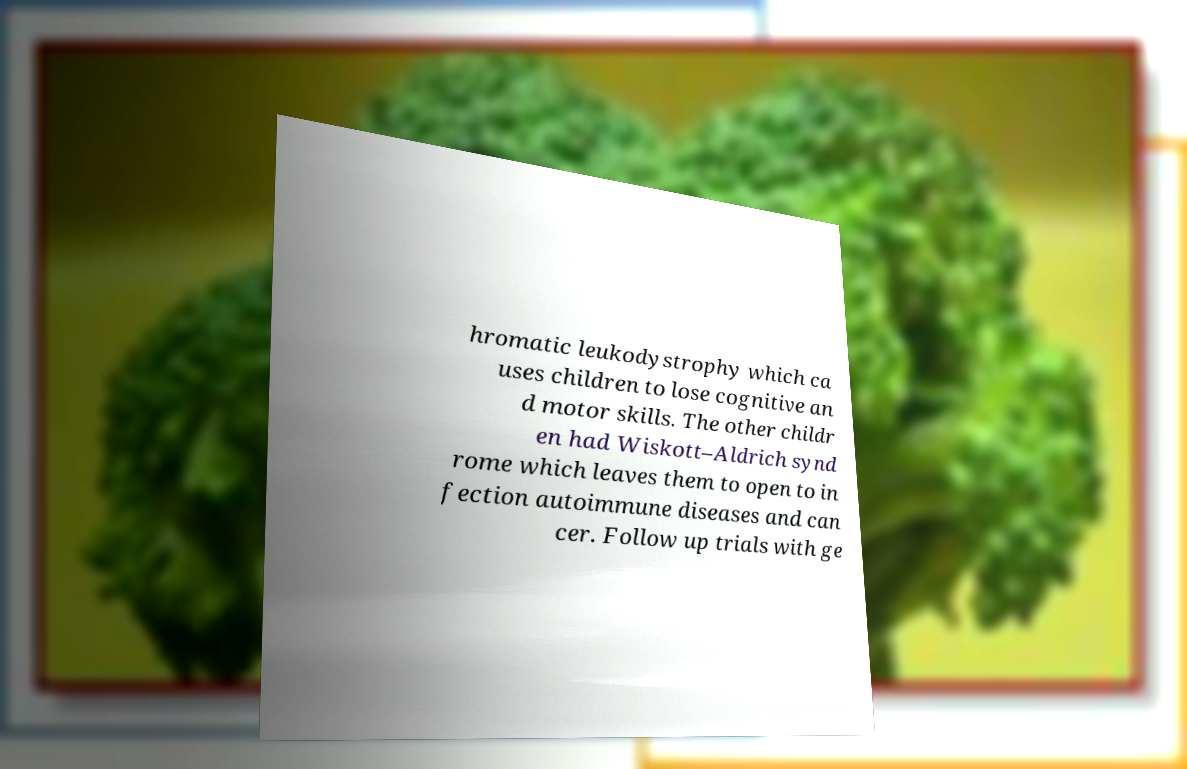Could you extract and type out the text from this image? hromatic leukodystrophy which ca uses children to lose cognitive an d motor skills. The other childr en had Wiskott–Aldrich synd rome which leaves them to open to in fection autoimmune diseases and can cer. Follow up trials with ge 